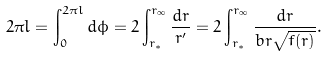<formula> <loc_0><loc_0><loc_500><loc_500>2 \pi l = \int _ { 0 } ^ { 2 \pi l } d \phi = 2 \int _ { r _ { * } } ^ { r _ { \infty } } \frac { d r } { r ^ { \prime } } = 2 \int _ { r _ { * } } ^ { r _ { \infty } } \frac { d r } { b r \sqrt { f ( r ) } } .</formula> 